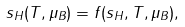Convert formula to latex. <formula><loc_0><loc_0><loc_500><loc_500>s _ { H } ( T , \mu _ { B } ) = f ( s _ { H } , T , \mu _ { B } ) ,</formula> 